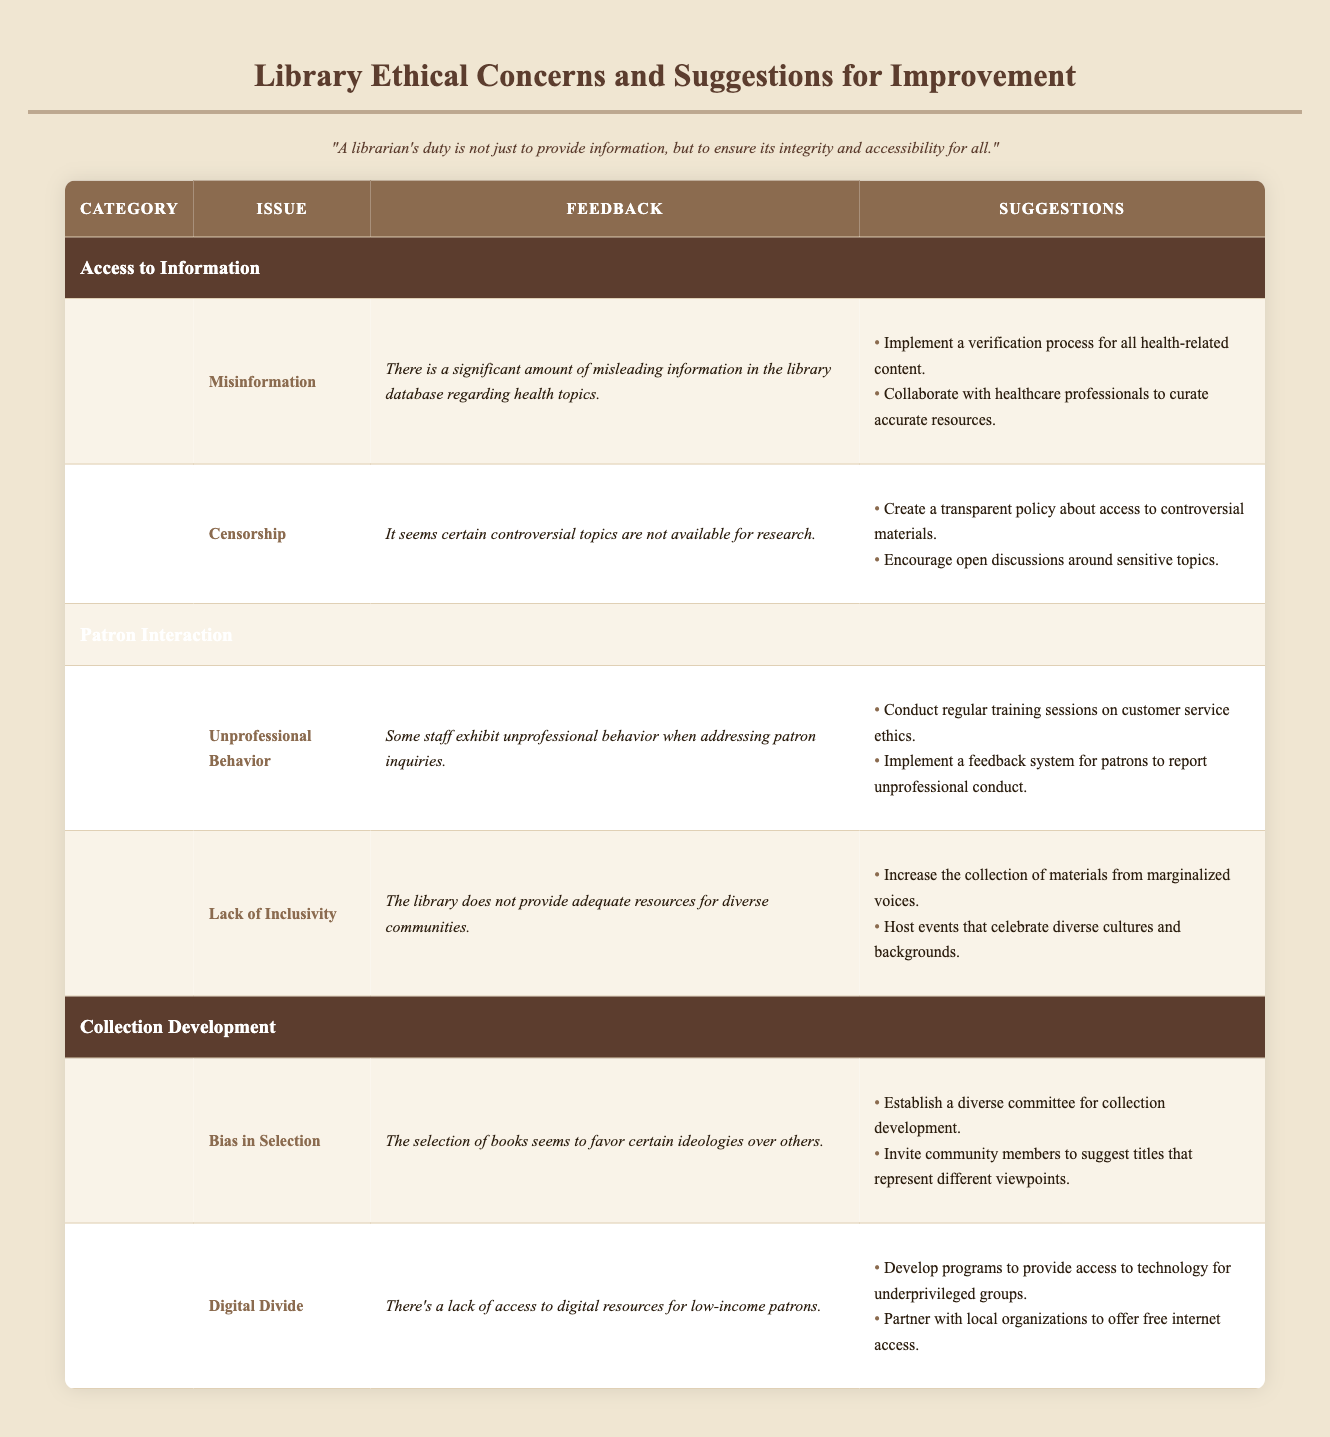What are the two main issues listed under the "Access to Information" category? The table indicates two issues in the "Access to Information" category: "Misinformation" and "Censorship." This is directly retrieved from the first category of the table.
Answer: Misinformation and Censorship How many suggestions are provided for the issue of "Unprofessional Behavior"? The table provides two suggestions for the "Unprofessional Behavior" issue: "Conduct regular training sessions on customer service ethics" and "Implement a feedback system for patrons to report unprofessional conduct." Count is straightforward from the table.
Answer: 2 Is there a suggestion to improve access to digital resources for low-income patrons? Yes, one of the suggestions under "Digital Divide" is to "Develop programs to provide access to technology for underprivileged groups." This is clearly mentioned in the table.
Answer: Yes Which category has the issue of a "Lack of Inclusivity"? The issue "Lack of Inclusivity" falls under the "Patron Interaction" category. This can be easily identified in the table.
Answer: Patron Interaction What is the main feedback regarding "Bias in Selection"? The feedback mentions that "The selection of books seems to favor certain ideologies over others," which can be found under the "Collection Development" category. This direct statement is listed in the table.
Answer: The selection of books seems to favor certain ideologies over others Which two categories provide suggestions focused on improving inclusivity? Both "Patron Interaction" and "Collection Development" provide suggestions focused on inclusivity. In "Patron Interaction," the suggestions include increasing materials from marginalized voices and hosting cultural events. In "Collection Development," inviting community suggestions also promotes inclusivity.
Answer: Patron Interaction and Collection Development What can be deduced about the overall concern regarding digital resources for low-income patrons? The feedback indicates a lack of access to digital resources for low-income patrons under the "Digital Divide" issue. This concern is an indication that certain groups are underserved, and the suggestion aims to bridge that gap. Thus, it reflects an ethical concern that needs addressing.
Answer: There is a lack of access, indicating an ethical concern How many suggestions are there in total under the "Collection Development" category? There are two issues listed: "Bias in Selection" and "Digital Divide." Each issue has two suggestions, resulting in a total of four suggestions across both issues. Thus, the total is calculated by adding the suggestions for each issue together.
Answer: 4 